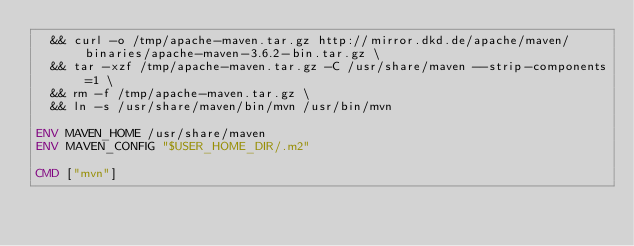Convert code to text. <code><loc_0><loc_0><loc_500><loc_500><_Dockerfile_>  && curl -o /tmp/apache-maven.tar.gz http://mirror.dkd.de/apache/maven/binaries/apache-maven-3.6.2-bin.tar.gz \
  && tar -xzf /tmp/apache-maven.tar.gz -C /usr/share/maven --strip-components=1 \
  && rm -f /tmp/apache-maven.tar.gz \
  && ln -s /usr/share/maven/bin/mvn /usr/bin/mvn

ENV MAVEN_HOME /usr/share/maven
ENV MAVEN_CONFIG "$USER_HOME_DIR/.m2"

CMD ["mvn"]</code> 